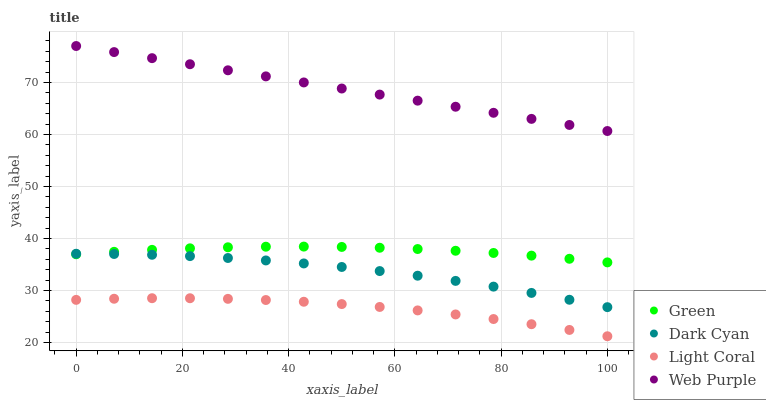Does Light Coral have the minimum area under the curve?
Answer yes or no. Yes. Does Web Purple have the maximum area under the curve?
Answer yes or no. Yes. Does Web Purple have the minimum area under the curve?
Answer yes or no. No. Does Light Coral have the maximum area under the curve?
Answer yes or no. No. Is Web Purple the smoothest?
Answer yes or no. Yes. Is Light Coral the roughest?
Answer yes or no. Yes. Is Light Coral the smoothest?
Answer yes or no. No. Is Web Purple the roughest?
Answer yes or no. No. Does Light Coral have the lowest value?
Answer yes or no. Yes. Does Web Purple have the lowest value?
Answer yes or no. No. Does Web Purple have the highest value?
Answer yes or no. Yes. Does Light Coral have the highest value?
Answer yes or no. No. Is Light Coral less than Dark Cyan?
Answer yes or no. Yes. Is Green greater than Light Coral?
Answer yes or no. Yes. Does Dark Cyan intersect Green?
Answer yes or no. Yes. Is Dark Cyan less than Green?
Answer yes or no. No. Is Dark Cyan greater than Green?
Answer yes or no. No. Does Light Coral intersect Dark Cyan?
Answer yes or no. No. 